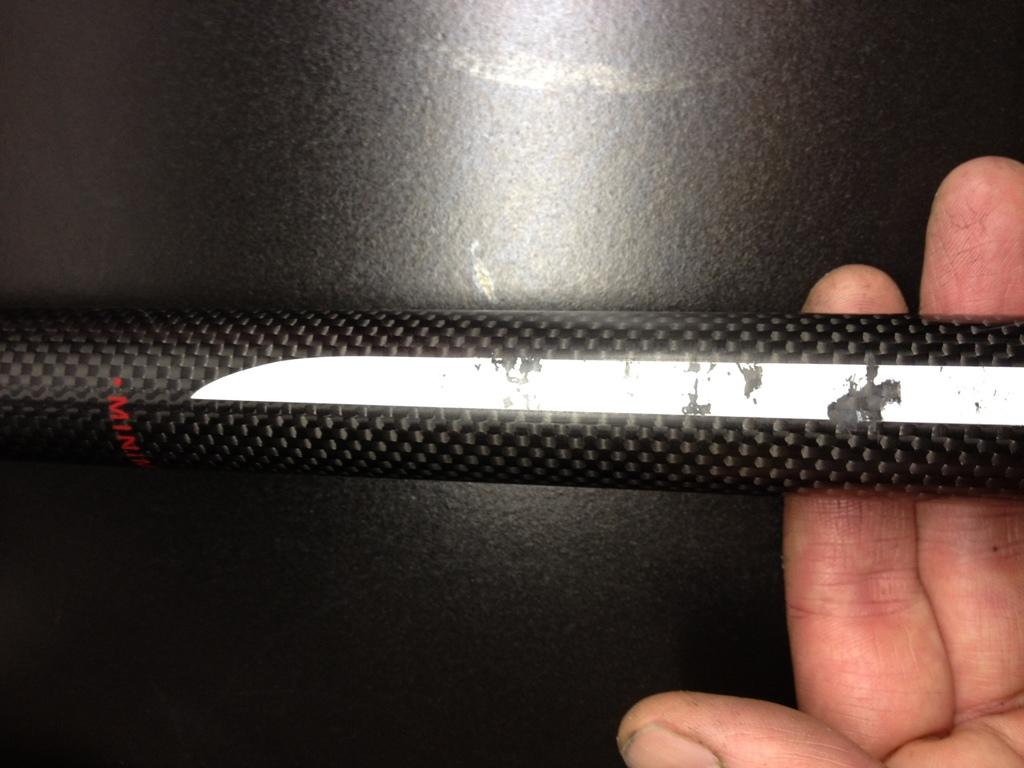What is present in the image? There is a person in the image. What is the person holding? The person is holding a rod. How many dogs are visible in the image? There are no dogs present in the image. What is the chance of winning a prize in the image? There is no mention of a prize or chance in the image. 